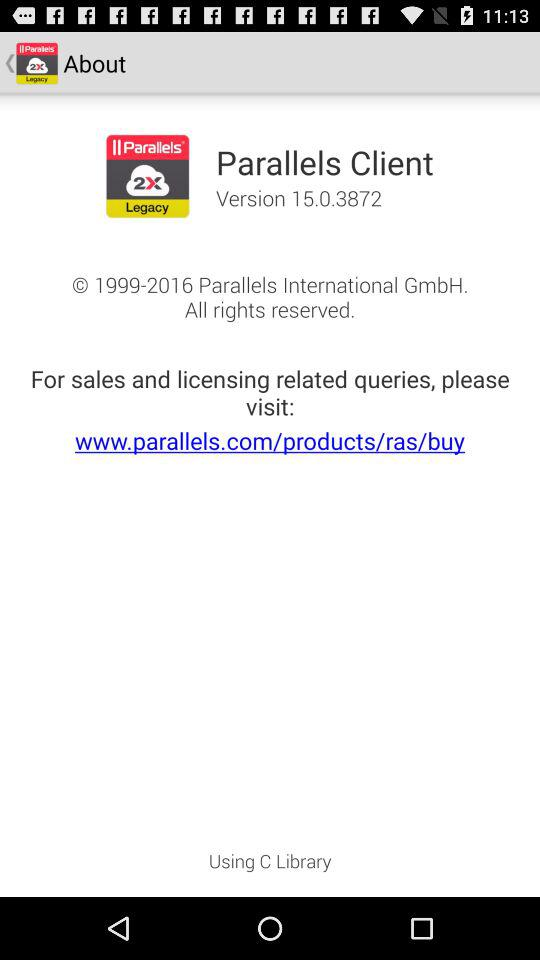What is the URL? The URL is www.parallels.com/products/ras/buy. 